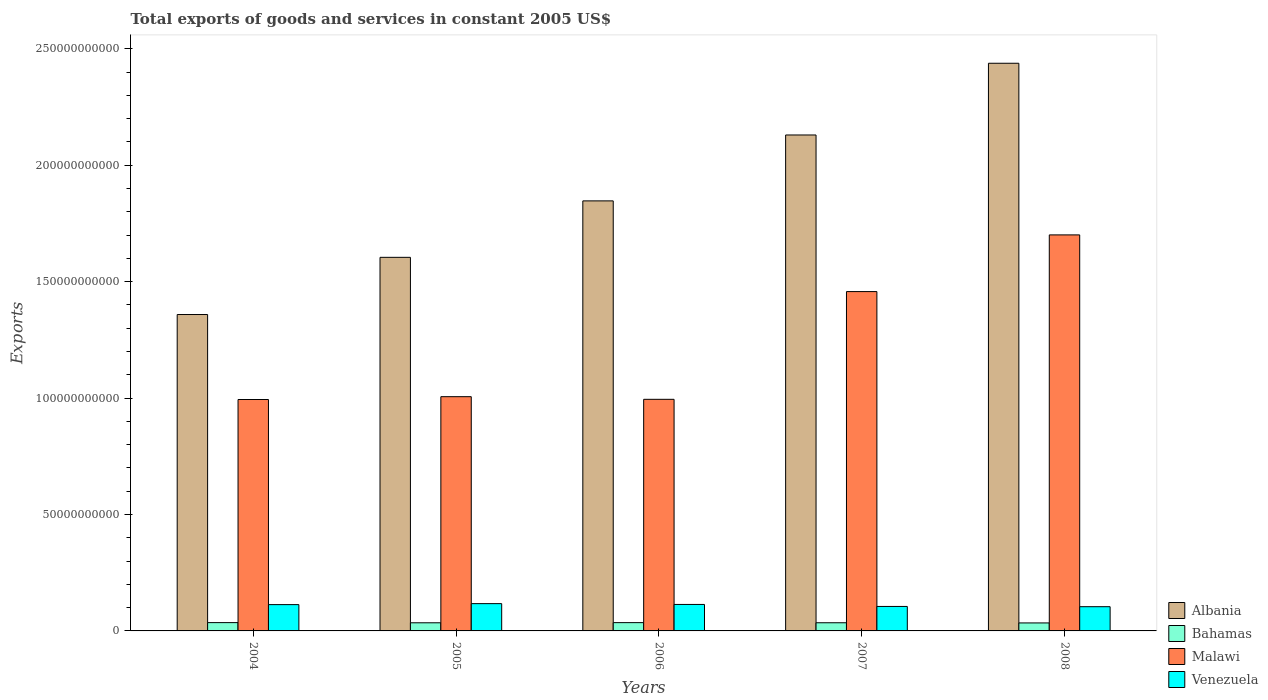How many groups of bars are there?
Give a very brief answer. 5. Are the number of bars per tick equal to the number of legend labels?
Keep it short and to the point. Yes. How many bars are there on the 4th tick from the left?
Offer a very short reply. 4. What is the label of the 1st group of bars from the left?
Keep it short and to the point. 2004. In how many cases, is the number of bars for a given year not equal to the number of legend labels?
Provide a short and direct response. 0. What is the total exports of goods and services in Bahamas in 2006?
Ensure brevity in your answer.  3.56e+09. Across all years, what is the maximum total exports of goods and services in Albania?
Provide a succinct answer. 2.44e+11. Across all years, what is the minimum total exports of goods and services in Venezuela?
Give a very brief answer. 1.04e+1. In which year was the total exports of goods and services in Bahamas maximum?
Offer a very short reply. 2004. What is the total total exports of goods and services in Malawi in the graph?
Your response must be concise. 6.15e+11. What is the difference between the total exports of goods and services in Malawi in 2004 and that in 2005?
Your answer should be very brief. -1.21e+09. What is the difference between the total exports of goods and services in Venezuela in 2008 and the total exports of goods and services in Malawi in 2004?
Provide a short and direct response. -8.90e+1. What is the average total exports of goods and services in Malawi per year?
Offer a very short reply. 1.23e+11. In the year 2004, what is the difference between the total exports of goods and services in Venezuela and total exports of goods and services in Malawi?
Provide a succinct answer. -8.81e+1. What is the ratio of the total exports of goods and services in Venezuela in 2006 to that in 2007?
Provide a succinct answer. 1.08. Is the total exports of goods and services in Venezuela in 2005 less than that in 2007?
Provide a short and direct response. No. Is the difference between the total exports of goods and services in Venezuela in 2007 and 2008 greater than the difference between the total exports of goods and services in Malawi in 2007 and 2008?
Your answer should be compact. Yes. What is the difference between the highest and the second highest total exports of goods and services in Albania?
Offer a terse response. 3.08e+1. What is the difference between the highest and the lowest total exports of goods and services in Venezuela?
Offer a very short reply. 1.32e+09. Is the sum of the total exports of goods and services in Malawi in 2007 and 2008 greater than the maximum total exports of goods and services in Bahamas across all years?
Your answer should be compact. Yes. Is it the case that in every year, the sum of the total exports of goods and services in Venezuela and total exports of goods and services in Malawi is greater than the sum of total exports of goods and services in Albania and total exports of goods and services in Bahamas?
Give a very brief answer. No. What does the 2nd bar from the left in 2004 represents?
Provide a short and direct response. Bahamas. What does the 1st bar from the right in 2005 represents?
Provide a short and direct response. Venezuela. How many years are there in the graph?
Provide a succinct answer. 5. What is the difference between two consecutive major ticks on the Y-axis?
Provide a short and direct response. 5.00e+1. Where does the legend appear in the graph?
Provide a short and direct response. Bottom right. How many legend labels are there?
Your answer should be very brief. 4. What is the title of the graph?
Give a very brief answer. Total exports of goods and services in constant 2005 US$. What is the label or title of the X-axis?
Your response must be concise. Years. What is the label or title of the Y-axis?
Make the answer very short. Exports. What is the Exports in Albania in 2004?
Make the answer very short. 1.36e+11. What is the Exports of Bahamas in 2004?
Ensure brevity in your answer.  3.57e+09. What is the Exports in Malawi in 2004?
Ensure brevity in your answer.  9.94e+1. What is the Exports of Venezuela in 2004?
Offer a very short reply. 1.13e+1. What is the Exports in Albania in 2005?
Provide a short and direct response. 1.60e+11. What is the Exports in Bahamas in 2005?
Ensure brevity in your answer.  3.49e+09. What is the Exports in Malawi in 2005?
Your answer should be compact. 1.01e+11. What is the Exports of Venezuela in 2005?
Your answer should be very brief. 1.17e+1. What is the Exports of Albania in 2006?
Provide a succinct answer. 1.85e+11. What is the Exports in Bahamas in 2006?
Provide a succinct answer. 3.56e+09. What is the Exports in Malawi in 2006?
Provide a succinct answer. 9.95e+1. What is the Exports of Venezuela in 2006?
Provide a short and direct response. 1.14e+1. What is the Exports in Albania in 2007?
Make the answer very short. 2.13e+11. What is the Exports of Bahamas in 2007?
Ensure brevity in your answer.  3.51e+09. What is the Exports in Malawi in 2007?
Make the answer very short. 1.46e+11. What is the Exports of Venezuela in 2007?
Offer a very short reply. 1.05e+1. What is the Exports in Albania in 2008?
Your response must be concise. 2.44e+11. What is the Exports of Bahamas in 2008?
Your answer should be compact. 3.43e+09. What is the Exports in Malawi in 2008?
Your response must be concise. 1.70e+11. What is the Exports in Venezuela in 2008?
Provide a succinct answer. 1.04e+1. Across all years, what is the maximum Exports of Albania?
Give a very brief answer. 2.44e+11. Across all years, what is the maximum Exports in Bahamas?
Keep it short and to the point. 3.57e+09. Across all years, what is the maximum Exports of Malawi?
Your response must be concise. 1.70e+11. Across all years, what is the maximum Exports of Venezuela?
Offer a very short reply. 1.17e+1. Across all years, what is the minimum Exports in Albania?
Ensure brevity in your answer.  1.36e+11. Across all years, what is the minimum Exports of Bahamas?
Offer a terse response. 3.43e+09. Across all years, what is the minimum Exports in Malawi?
Provide a succinct answer. 9.94e+1. Across all years, what is the minimum Exports in Venezuela?
Offer a terse response. 1.04e+1. What is the total Exports of Albania in the graph?
Ensure brevity in your answer.  9.38e+11. What is the total Exports in Bahamas in the graph?
Provide a succinct answer. 1.75e+1. What is the total Exports in Malawi in the graph?
Provide a short and direct response. 6.15e+11. What is the total Exports of Venezuela in the graph?
Make the answer very short. 5.53e+1. What is the difference between the Exports of Albania in 2004 and that in 2005?
Ensure brevity in your answer.  -2.46e+1. What is the difference between the Exports in Bahamas in 2004 and that in 2005?
Keep it short and to the point. 7.63e+07. What is the difference between the Exports in Malawi in 2004 and that in 2005?
Ensure brevity in your answer.  -1.21e+09. What is the difference between the Exports in Venezuela in 2004 and that in 2005?
Your response must be concise. -4.26e+08. What is the difference between the Exports in Albania in 2004 and that in 2006?
Provide a succinct answer. -4.88e+1. What is the difference between the Exports in Bahamas in 2004 and that in 2006?
Your response must be concise. 8.48e+06. What is the difference between the Exports in Malawi in 2004 and that in 2006?
Your answer should be compact. -7.75e+07. What is the difference between the Exports of Venezuela in 2004 and that in 2006?
Make the answer very short. -7.21e+07. What is the difference between the Exports in Albania in 2004 and that in 2007?
Your response must be concise. -7.71e+1. What is the difference between the Exports of Bahamas in 2004 and that in 2007?
Provide a short and direct response. 5.92e+07. What is the difference between the Exports of Malawi in 2004 and that in 2007?
Ensure brevity in your answer.  -4.63e+1. What is the difference between the Exports in Venezuela in 2004 and that in 2007?
Give a very brief answer. 7.86e+08. What is the difference between the Exports of Albania in 2004 and that in 2008?
Provide a succinct answer. -1.08e+11. What is the difference between the Exports in Bahamas in 2004 and that in 2008?
Give a very brief answer. 1.36e+08. What is the difference between the Exports of Malawi in 2004 and that in 2008?
Provide a short and direct response. -7.07e+1. What is the difference between the Exports of Venezuela in 2004 and that in 2008?
Your answer should be very brief. 8.90e+08. What is the difference between the Exports in Albania in 2005 and that in 2006?
Provide a succinct answer. -2.42e+1. What is the difference between the Exports of Bahamas in 2005 and that in 2006?
Keep it short and to the point. -6.78e+07. What is the difference between the Exports of Malawi in 2005 and that in 2006?
Provide a succinct answer. 1.13e+09. What is the difference between the Exports in Venezuela in 2005 and that in 2006?
Keep it short and to the point. 3.54e+08. What is the difference between the Exports in Albania in 2005 and that in 2007?
Provide a succinct answer. -5.25e+1. What is the difference between the Exports of Bahamas in 2005 and that in 2007?
Offer a very short reply. -1.71e+07. What is the difference between the Exports of Malawi in 2005 and that in 2007?
Give a very brief answer. -4.51e+1. What is the difference between the Exports in Venezuela in 2005 and that in 2007?
Your answer should be compact. 1.21e+09. What is the difference between the Exports of Albania in 2005 and that in 2008?
Make the answer very short. -8.33e+1. What is the difference between the Exports in Bahamas in 2005 and that in 2008?
Keep it short and to the point. 6.01e+07. What is the difference between the Exports in Malawi in 2005 and that in 2008?
Provide a succinct answer. -6.95e+1. What is the difference between the Exports in Venezuela in 2005 and that in 2008?
Offer a terse response. 1.32e+09. What is the difference between the Exports in Albania in 2006 and that in 2007?
Keep it short and to the point. -2.83e+1. What is the difference between the Exports of Bahamas in 2006 and that in 2007?
Your answer should be compact. 5.07e+07. What is the difference between the Exports of Malawi in 2006 and that in 2007?
Ensure brevity in your answer.  -4.63e+1. What is the difference between the Exports of Venezuela in 2006 and that in 2007?
Provide a short and direct response. 8.58e+08. What is the difference between the Exports of Albania in 2006 and that in 2008?
Offer a terse response. -5.91e+1. What is the difference between the Exports in Bahamas in 2006 and that in 2008?
Your response must be concise. 1.28e+08. What is the difference between the Exports of Malawi in 2006 and that in 2008?
Provide a succinct answer. -7.06e+1. What is the difference between the Exports of Venezuela in 2006 and that in 2008?
Your answer should be compact. 9.62e+08. What is the difference between the Exports of Albania in 2007 and that in 2008?
Your response must be concise. -3.08e+1. What is the difference between the Exports of Bahamas in 2007 and that in 2008?
Offer a terse response. 7.72e+07. What is the difference between the Exports of Malawi in 2007 and that in 2008?
Offer a terse response. -2.43e+1. What is the difference between the Exports of Venezuela in 2007 and that in 2008?
Provide a short and direct response. 1.03e+08. What is the difference between the Exports in Albania in 2004 and the Exports in Bahamas in 2005?
Your answer should be very brief. 1.32e+11. What is the difference between the Exports in Albania in 2004 and the Exports in Malawi in 2005?
Your response must be concise. 3.53e+1. What is the difference between the Exports in Albania in 2004 and the Exports in Venezuela in 2005?
Provide a succinct answer. 1.24e+11. What is the difference between the Exports of Bahamas in 2004 and the Exports of Malawi in 2005?
Your answer should be compact. -9.70e+1. What is the difference between the Exports in Bahamas in 2004 and the Exports in Venezuela in 2005?
Offer a terse response. -8.16e+09. What is the difference between the Exports of Malawi in 2004 and the Exports of Venezuela in 2005?
Provide a short and direct response. 8.77e+1. What is the difference between the Exports of Albania in 2004 and the Exports of Bahamas in 2006?
Provide a succinct answer. 1.32e+11. What is the difference between the Exports of Albania in 2004 and the Exports of Malawi in 2006?
Ensure brevity in your answer.  3.64e+1. What is the difference between the Exports in Albania in 2004 and the Exports in Venezuela in 2006?
Ensure brevity in your answer.  1.25e+11. What is the difference between the Exports of Bahamas in 2004 and the Exports of Malawi in 2006?
Offer a terse response. -9.59e+1. What is the difference between the Exports of Bahamas in 2004 and the Exports of Venezuela in 2006?
Give a very brief answer. -7.80e+09. What is the difference between the Exports in Malawi in 2004 and the Exports in Venezuela in 2006?
Offer a very short reply. 8.80e+1. What is the difference between the Exports in Albania in 2004 and the Exports in Bahamas in 2007?
Provide a succinct answer. 1.32e+11. What is the difference between the Exports in Albania in 2004 and the Exports in Malawi in 2007?
Your answer should be compact. -9.85e+09. What is the difference between the Exports in Albania in 2004 and the Exports in Venezuela in 2007?
Offer a very short reply. 1.25e+11. What is the difference between the Exports in Bahamas in 2004 and the Exports in Malawi in 2007?
Your answer should be very brief. -1.42e+11. What is the difference between the Exports in Bahamas in 2004 and the Exports in Venezuela in 2007?
Offer a terse response. -6.94e+09. What is the difference between the Exports in Malawi in 2004 and the Exports in Venezuela in 2007?
Keep it short and to the point. 8.89e+1. What is the difference between the Exports of Albania in 2004 and the Exports of Bahamas in 2008?
Ensure brevity in your answer.  1.32e+11. What is the difference between the Exports in Albania in 2004 and the Exports in Malawi in 2008?
Offer a terse response. -3.42e+1. What is the difference between the Exports of Albania in 2004 and the Exports of Venezuela in 2008?
Provide a short and direct response. 1.25e+11. What is the difference between the Exports in Bahamas in 2004 and the Exports in Malawi in 2008?
Offer a very short reply. -1.67e+11. What is the difference between the Exports of Bahamas in 2004 and the Exports of Venezuela in 2008?
Provide a succinct answer. -6.84e+09. What is the difference between the Exports of Malawi in 2004 and the Exports of Venezuela in 2008?
Your answer should be very brief. 8.90e+1. What is the difference between the Exports of Albania in 2005 and the Exports of Bahamas in 2006?
Provide a short and direct response. 1.57e+11. What is the difference between the Exports in Albania in 2005 and the Exports in Malawi in 2006?
Keep it short and to the point. 6.10e+1. What is the difference between the Exports of Albania in 2005 and the Exports of Venezuela in 2006?
Give a very brief answer. 1.49e+11. What is the difference between the Exports of Bahamas in 2005 and the Exports of Malawi in 2006?
Offer a very short reply. -9.60e+1. What is the difference between the Exports in Bahamas in 2005 and the Exports in Venezuela in 2006?
Keep it short and to the point. -7.88e+09. What is the difference between the Exports of Malawi in 2005 and the Exports of Venezuela in 2006?
Your response must be concise. 8.92e+1. What is the difference between the Exports in Albania in 2005 and the Exports in Bahamas in 2007?
Your response must be concise. 1.57e+11. What is the difference between the Exports of Albania in 2005 and the Exports of Malawi in 2007?
Give a very brief answer. 1.47e+1. What is the difference between the Exports of Albania in 2005 and the Exports of Venezuela in 2007?
Provide a short and direct response. 1.50e+11. What is the difference between the Exports in Bahamas in 2005 and the Exports in Malawi in 2007?
Give a very brief answer. -1.42e+11. What is the difference between the Exports of Bahamas in 2005 and the Exports of Venezuela in 2007?
Provide a succinct answer. -7.02e+09. What is the difference between the Exports in Malawi in 2005 and the Exports in Venezuela in 2007?
Provide a succinct answer. 9.01e+1. What is the difference between the Exports in Albania in 2005 and the Exports in Bahamas in 2008?
Your answer should be compact. 1.57e+11. What is the difference between the Exports in Albania in 2005 and the Exports in Malawi in 2008?
Keep it short and to the point. -9.64e+09. What is the difference between the Exports of Albania in 2005 and the Exports of Venezuela in 2008?
Ensure brevity in your answer.  1.50e+11. What is the difference between the Exports of Bahamas in 2005 and the Exports of Malawi in 2008?
Provide a short and direct response. -1.67e+11. What is the difference between the Exports of Bahamas in 2005 and the Exports of Venezuela in 2008?
Offer a very short reply. -6.92e+09. What is the difference between the Exports in Malawi in 2005 and the Exports in Venezuela in 2008?
Provide a short and direct response. 9.02e+1. What is the difference between the Exports of Albania in 2006 and the Exports of Bahamas in 2007?
Offer a very short reply. 1.81e+11. What is the difference between the Exports in Albania in 2006 and the Exports in Malawi in 2007?
Your answer should be very brief. 3.90e+1. What is the difference between the Exports of Albania in 2006 and the Exports of Venezuela in 2007?
Your answer should be compact. 1.74e+11. What is the difference between the Exports of Bahamas in 2006 and the Exports of Malawi in 2007?
Offer a very short reply. -1.42e+11. What is the difference between the Exports of Bahamas in 2006 and the Exports of Venezuela in 2007?
Provide a succinct answer. -6.95e+09. What is the difference between the Exports in Malawi in 2006 and the Exports in Venezuela in 2007?
Your answer should be very brief. 8.90e+1. What is the difference between the Exports of Albania in 2006 and the Exports of Bahamas in 2008?
Offer a terse response. 1.81e+11. What is the difference between the Exports of Albania in 2006 and the Exports of Malawi in 2008?
Offer a terse response. 1.46e+1. What is the difference between the Exports of Albania in 2006 and the Exports of Venezuela in 2008?
Offer a very short reply. 1.74e+11. What is the difference between the Exports of Bahamas in 2006 and the Exports of Malawi in 2008?
Offer a terse response. -1.67e+11. What is the difference between the Exports in Bahamas in 2006 and the Exports in Venezuela in 2008?
Make the answer very short. -6.85e+09. What is the difference between the Exports in Malawi in 2006 and the Exports in Venezuela in 2008?
Provide a succinct answer. 8.91e+1. What is the difference between the Exports in Albania in 2007 and the Exports in Bahamas in 2008?
Give a very brief answer. 2.10e+11. What is the difference between the Exports of Albania in 2007 and the Exports of Malawi in 2008?
Ensure brevity in your answer.  4.29e+1. What is the difference between the Exports in Albania in 2007 and the Exports in Venezuela in 2008?
Your answer should be very brief. 2.03e+11. What is the difference between the Exports of Bahamas in 2007 and the Exports of Malawi in 2008?
Your response must be concise. -1.67e+11. What is the difference between the Exports in Bahamas in 2007 and the Exports in Venezuela in 2008?
Offer a terse response. -6.90e+09. What is the difference between the Exports in Malawi in 2007 and the Exports in Venezuela in 2008?
Offer a terse response. 1.35e+11. What is the average Exports of Albania per year?
Provide a succinct answer. 1.88e+11. What is the average Exports of Bahamas per year?
Keep it short and to the point. 3.51e+09. What is the average Exports of Malawi per year?
Ensure brevity in your answer.  1.23e+11. What is the average Exports in Venezuela per year?
Give a very brief answer. 1.11e+1. In the year 2004, what is the difference between the Exports in Albania and Exports in Bahamas?
Offer a terse response. 1.32e+11. In the year 2004, what is the difference between the Exports in Albania and Exports in Malawi?
Provide a short and direct response. 3.65e+1. In the year 2004, what is the difference between the Exports in Albania and Exports in Venezuela?
Ensure brevity in your answer.  1.25e+11. In the year 2004, what is the difference between the Exports of Bahamas and Exports of Malawi?
Your answer should be compact. -9.58e+1. In the year 2004, what is the difference between the Exports of Bahamas and Exports of Venezuela?
Your response must be concise. -7.73e+09. In the year 2004, what is the difference between the Exports of Malawi and Exports of Venezuela?
Make the answer very short. 8.81e+1. In the year 2005, what is the difference between the Exports of Albania and Exports of Bahamas?
Your answer should be very brief. 1.57e+11. In the year 2005, what is the difference between the Exports of Albania and Exports of Malawi?
Provide a succinct answer. 5.98e+1. In the year 2005, what is the difference between the Exports of Albania and Exports of Venezuela?
Offer a terse response. 1.49e+11. In the year 2005, what is the difference between the Exports of Bahamas and Exports of Malawi?
Provide a succinct answer. -9.71e+1. In the year 2005, what is the difference between the Exports of Bahamas and Exports of Venezuela?
Keep it short and to the point. -8.23e+09. In the year 2005, what is the difference between the Exports of Malawi and Exports of Venezuela?
Offer a terse response. 8.89e+1. In the year 2006, what is the difference between the Exports in Albania and Exports in Bahamas?
Offer a very short reply. 1.81e+11. In the year 2006, what is the difference between the Exports of Albania and Exports of Malawi?
Your response must be concise. 8.52e+1. In the year 2006, what is the difference between the Exports in Albania and Exports in Venezuela?
Keep it short and to the point. 1.73e+11. In the year 2006, what is the difference between the Exports of Bahamas and Exports of Malawi?
Provide a succinct answer. -9.59e+1. In the year 2006, what is the difference between the Exports of Bahamas and Exports of Venezuela?
Your answer should be compact. -7.81e+09. In the year 2006, what is the difference between the Exports of Malawi and Exports of Venezuela?
Provide a succinct answer. 8.81e+1. In the year 2007, what is the difference between the Exports in Albania and Exports in Bahamas?
Offer a terse response. 2.09e+11. In the year 2007, what is the difference between the Exports in Albania and Exports in Malawi?
Ensure brevity in your answer.  6.73e+1. In the year 2007, what is the difference between the Exports in Albania and Exports in Venezuela?
Offer a terse response. 2.02e+11. In the year 2007, what is the difference between the Exports of Bahamas and Exports of Malawi?
Ensure brevity in your answer.  -1.42e+11. In the year 2007, what is the difference between the Exports of Bahamas and Exports of Venezuela?
Provide a short and direct response. -7.00e+09. In the year 2007, what is the difference between the Exports of Malawi and Exports of Venezuela?
Give a very brief answer. 1.35e+11. In the year 2008, what is the difference between the Exports of Albania and Exports of Bahamas?
Ensure brevity in your answer.  2.40e+11. In the year 2008, what is the difference between the Exports in Albania and Exports in Malawi?
Your answer should be very brief. 7.37e+1. In the year 2008, what is the difference between the Exports in Albania and Exports in Venezuela?
Provide a succinct answer. 2.33e+11. In the year 2008, what is the difference between the Exports in Bahamas and Exports in Malawi?
Offer a terse response. -1.67e+11. In the year 2008, what is the difference between the Exports in Bahamas and Exports in Venezuela?
Make the answer very short. -6.98e+09. In the year 2008, what is the difference between the Exports in Malawi and Exports in Venezuela?
Your answer should be compact. 1.60e+11. What is the ratio of the Exports in Albania in 2004 to that in 2005?
Keep it short and to the point. 0.85. What is the ratio of the Exports of Bahamas in 2004 to that in 2005?
Your answer should be compact. 1.02. What is the ratio of the Exports in Malawi in 2004 to that in 2005?
Provide a short and direct response. 0.99. What is the ratio of the Exports in Venezuela in 2004 to that in 2005?
Your answer should be very brief. 0.96. What is the ratio of the Exports of Albania in 2004 to that in 2006?
Your answer should be compact. 0.74. What is the ratio of the Exports in Bahamas in 2004 to that in 2006?
Offer a very short reply. 1. What is the ratio of the Exports in Albania in 2004 to that in 2007?
Your response must be concise. 0.64. What is the ratio of the Exports in Bahamas in 2004 to that in 2007?
Your response must be concise. 1.02. What is the ratio of the Exports in Malawi in 2004 to that in 2007?
Your response must be concise. 0.68. What is the ratio of the Exports of Venezuela in 2004 to that in 2007?
Offer a terse response. 1.07. What is the ratio of the Exports of Albania in 2004 to that in 2008?
Your response must be concise. 0.56. What is the ratio of the Exports of Bahamas in 2004 to that in 2008?
Ensure brevity in your answer.  1.04. What is the ratio of the Exports of Malawi in 2004 to that in 2008?
Offer a very short reply. 0.58. What is the ratio of the Exports of Venezuela in 2004 to that in 2008?
Ensure brevity in your answer.  1.09. What is the ratio of the Exports of Albania in 2005 to that in 2006?
Ensure brevity in your answer.  0.87. What is the ratio of the Exports of Bahamas in 2005 to that in 2006?
Your response must be concise. 0.98. What is the ratio of the Exports of Malawi in 2005 to that in 2006?
Your answer should be very brief. 1.01. What is the ratio of the Exports in Venezuela in 2005 to that in 2006?
Offer a terse response. 1.03. What is the ratio of the Exports in Albania in 2005 to that in 2007?
Offer a terse response. 0.75. What is the ratio of the Exports in Malawi in 2005 to that in 2007?
Offer a very short reply. 0.69. What is the ratio of the Exports of Venezuela in 2005 to that in 2007?
Your answer should be very brief. 1.12. What is the ratio of the Exports in Albania in 2005 to that in 2008?
Make the answer very short. 0.66. What is the ratio of the Exports in Bahamas in 2005 to that in 2008?
Make the answer very short. 1.02. What is the ratio of the Exports in Malawi in 2005 to that in 2008?
Provide a succinct answer. 0.59. What is the ratio of the Exports in Venezuela in 2005 to that in 2008?
Your answer should be compact. 1.13. What is the ratio of the Exports of Albania in 2006 to that in 2007?
Provide a succinct answer. 0.87. What is the ratio of the Exports of Bahamas in 2006 to that in 2007?
Your answer should be very brief. 1.01. What is the ratio of the Exports in Malawi in 2006 to that in 2007?
Your answer should be compact. 0.68. What is the ratio of the Exports of Venezuela in 2006 to that in 2007?
Your answer should be compact. 1.08. What is the ratio of the Exports of Albania in 2006 to that in 2008?
Make the answer very short. 0.76. What is the ratio of the Exports of Bahamas in 2006 to that in 2008?
Provide a short and direct response. 1.04. What is the ratio of the Exports in Malawi in 2006 to that in 2008?
Give a very brief answer. 0.58. What is the ratio of the Exports in Venezuela in 2006 to that in 2008?
Your answer should be very brief. 1.09. What is the ratio of the Exports of Albania in 2007 to that in 2008?
Give a very brief answer. 0.87. What is the ratio of the Exports of Bahamas in 2007 to that in 2008?
Provide a short and direct response. 1.02. What is the ratio of the Exports in Malawi in 2007 to that in 2008?
Ensure brevity in your answer.  0.86. What is the ratio of the Exports of Venezuela in 2007 to that in 2008?
Offer a very short reply. 1.01. What is the difference between the highest and the second highest Exports of Albania?
Offer a very short reply. 3.08e+1. What is the difference between the highest and the second highest Exports in Bahamas?
Provide a short and direct response. 8.48e+06. What is the difference between the highest and the second highest Exports of Malawi?
Your response must be concise. 2.43e+1. What is the difference between the highest and the second highest Exports in Venezuela?
Ensure brevity in your answer.  3.54e+08. What is the difference between the highest and the lowest Exports in Albania?
Offer a terse response. 1.08e+11. What is the difference between the highest and the lowest Exports of Bahamas?
Your answer should be compact. 1.36e+08. What is the difference between the highest and the lowest Exports of Malawi?
Provide a short and direct response. 7.07e+1. What is the difference between the highest and the lowest Exports of Venezuela?
Keep it short and to the point. 1.32e+09. 